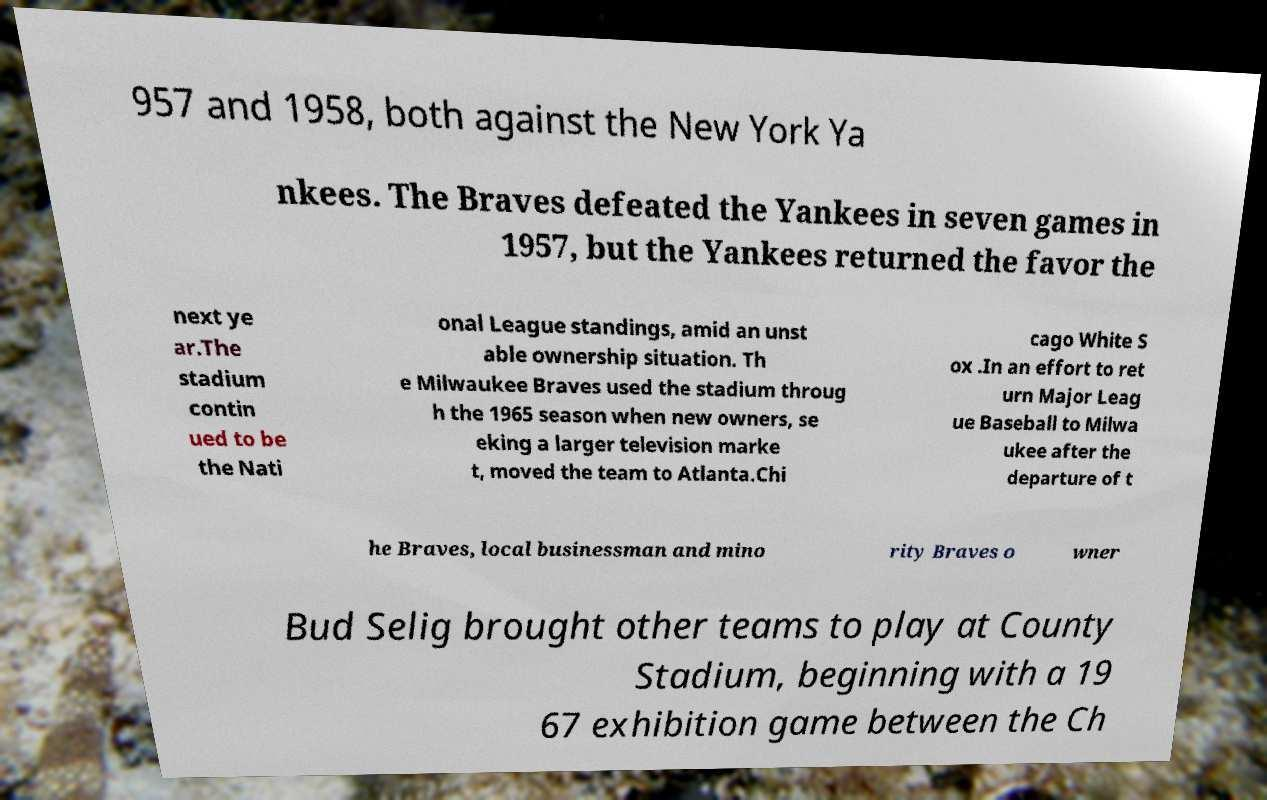Please identify and transcribe the text found in this image. 957 and 1958, both against the New York Ya nkees. The Braves defeated the Yankees in seven games in 1957, but the Yankees returned the favor the next ye ar.The stadium contin ued to be the Nati onal League standings, amid an unst able ownership situation. Th e Milwaukee Braves used the stadium throug h the 1965 season when new owners, se eking a larger television marke t, moved the team to Atlanta.Chi cago White S ox .In an effort to ret urn Major Leag ue Baseball to Milwa ukee after the departure of t he Braves, local businessman and mino rity Braves o wner Bud Selig brought other teams to play at County Stadium, beginning with a 19 67 exhibition game between the Ch 